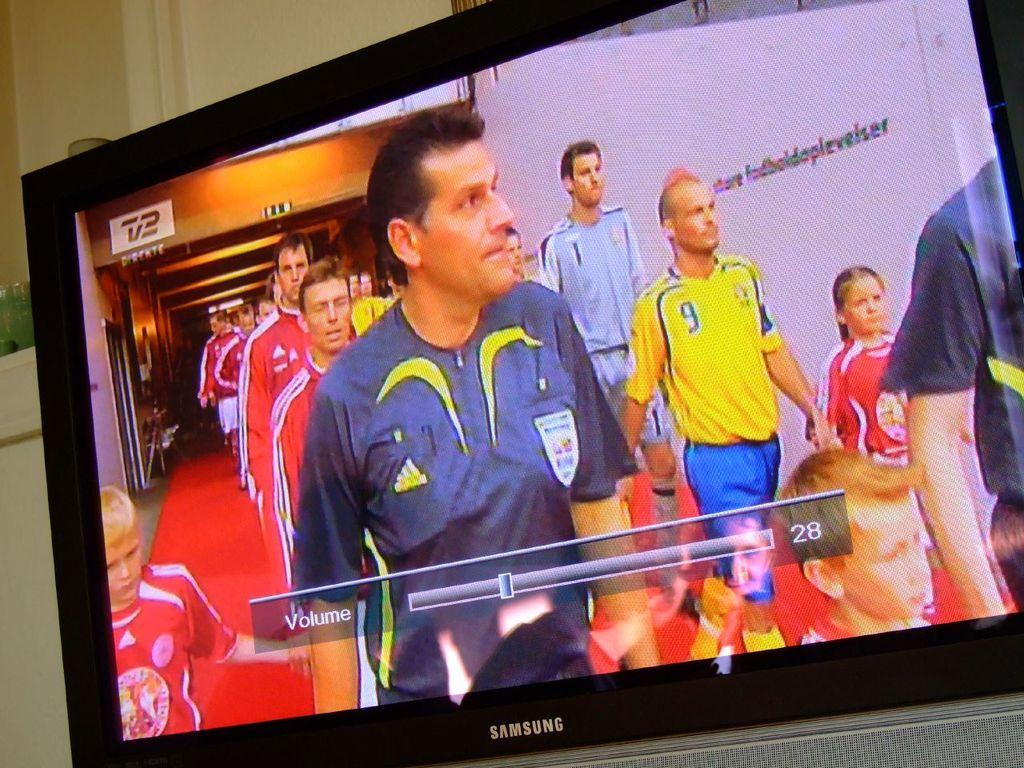<image>
Relay a brief, clear account of the picture shown. The TV volume bar is set to 28 